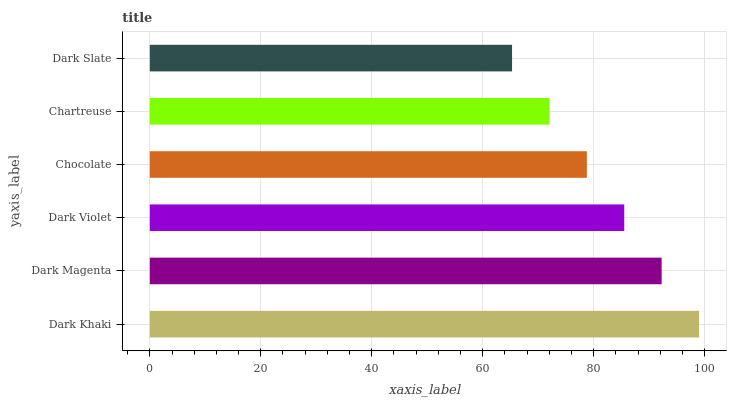Is Dark Slate the minimum?
Answer yes or no. Yes. Is Dark Khaki the maximum?
Answer yes or no. Yes. Is Dark Magenta the minimum?
Answer yes or no. No. Is Dark Magenta the maximum?
Answer yes or no. No. Is Dark Khaki greater than Dark Magenta?
Answer yes or no. Yes. Is Dark Magenta less than Dark Khaki?
Answer yes or no. Yes. Is Dark Magenta greater than Dark Khaki?
Answer yes or no. No. Is Dark Khaki less than Dark Magenta?
Answer yes or no. No. Is Dark Violet the high median?
Answer yes or no. Yes. Is Chocolate the low median?
Answer yes or no. Yes. Is Dark Magenta the high median?
Answer yes or no. No. Is Dark Khaki the low median?
Answer yes or no. No. 